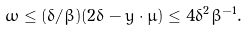Convert formula to latex. <formula><loc_0><loc_0><loc_500><loc_500>\omega \leq ( \delta / \beta ) ( 2 \delta - y \cdot \mu ) \leq 4 \delta ^ { 2 } \beta ^ { - 1 } .</formula> 